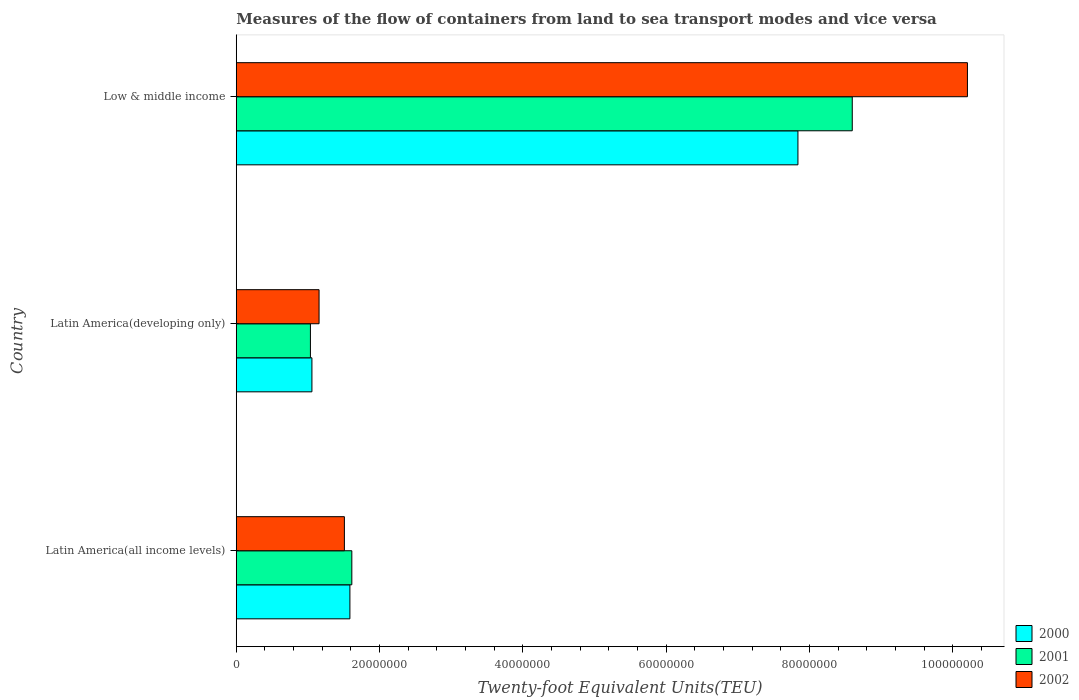How many different coloured bars are there?
Give a very brief answer. 3. How many groups of bars are there?
Offer a terse response. 3. Are the number of bars per tick equal to the number of legend labels?
Ensure brevity in your answer.  Yes. Are the number of bars on each tick of the Y-axis equal?
Make the answer very short. Yes. How many bars are there on the 2nd tick from the top?
Offer a terse response. 3. What is the label of the 2nd group of bars from the top?
Ensure brevity in your answer.  Latin America(developing only). In how many cases, is the number of bars for a given country not equal to the number of legend labels?
Keep it short and to the point. 0. What is the container port traffic in 2001 in Latin America(developing only)?
Offer a terse response. 1.04e+07. Across all countries, what is the maximum container port traffic in 2002?
Offer a terse response. 1.02e+08. Across all countries, what is the minimum container port traffic in 2001?
Offer a very short reply. 1.04e+07. In which country was the container port traffic in 2002 maximum?
Your answer should be compact. Low & middle income. In which country was the container port traffic in 2002 minimum?
Offer a terse response. Latin America(developing only). What is the total container port traffic in 2001 in the graph?
Provide a succinct answer. 1.12e+08. What is the difference between the container port traffic in 2002 in Latin America(all income levels) and that in Low & middle income?
Your response must be concise. -8.69e+07. What is the difference between the container port traffic in 2000 in Latin America(all income levels) and the container port traffic in 2002 in Low & middle income?
Ensure brevity in your answer.  -8.62e+07. What is the average container port traffic in 2000 per country?
Offer a terse response. 3.49e+07. What is the difference between the container port traffic in 2002 and container port traffic in 2000 in Latin America(all income levels)?
Ensure brevity in your answer.  -7.70e+05. In how many countries, is the container port traffic in 2001 greater than 64000000 TEU?
Your answer should be very brief. 1. What is the ratio of the container port traffic in 2002 in Latin America(developing only) to that in Low & middle income?
Offer a very short reply. 0.11. Is the container port traffic in 2002 in Latin America(all income levels) less than that in Latin America(developing only)?
Give a very brief answer. No. What is the difference between the highest and the second highest container port traffic in 2002?
Your response must be concise. 8.69e+07. What is the difference between the highest and the lowest container port traffic in 2002?
Provide a short and direct response. 9.05e+07. In how many countries, is the container port traffic in 2002 greater than the average container port traffic in 2002 taken over all countries?
Keep it short and to the point. 1. Is the sum of the container port traffic in 2002 in Latin America(developing only) and Low & middle income greater than the maximum container port traffic in 2001 across all countries?
Your answer should be very brief. Yes. What does the 2nd bar from the top in Latin America(developing only) represents?
Provide a short and direct response. 2001. What does the 3rd bar from the bottom in Latin America(developing only) represents?
Offer a very short reply. 2002. Is it the case that in every country, the sum of the container port traffic in 2001 and container port traffic in 2000 is greater than the container port traffic in 2002?
Your answer should be very brief. Yes. How many bars are there?
Your answer should be very brief. 9. What is the difference between two consecutive major ticks on the X-axis?
Give a very brief answer. 2.00e+07. Does the graph contain any zero values?
Ensure brevity in your answer.  No. Does the graph contain grids?
Ensure brevity in your answer.  No. Where does the legend appear in the graph?
Your answer should be very brief. Bottom right. How many legend labels are there?
Your answer should be very brief. 3. How are the legend labels stacked?
Give a very brief answer. Vertical. What is the title of the graph?
Provide a succinct answer. Measures of the flow of containers from land to sea transport modes and vice versa. Does "2009" appear as one of the legend labels in the graph?
Provide a succinct answer. No. What is the label or title of the X-axis?
Offer a terse response. Twenty-foot Equivalent Units(TEU). What is the label or title of the Y-axis?
Ensure brevity in your answer.  Country. What is the Twenty-foot Equivalent Units(TEU) of 2000 in Latin America(all income levels)?
Your response must be concise. 1.59e+07. What is the Twenty-foot Equivalent Units(TEU) of 2001 in Latin America(all income levels)?
Your response must be concise. 1.61e+07. What is the Twenty-foot Equivalent Units(TEU) in 2002 in Latin America(all income levels)?
Your answer should be very brief. 1.51e+07. What is the Twenty-foot Equivalent Units(TEU) in 2000 in Latin America(developing only)?
Your answer should be compact. 1.06e+07. What is the Twenty-foot Equivalent Units(TEU) in 2001 in Latin America(developing only)?
Your response must be concise. 1.04e+07. What is the Twenty-foot Equivalent Units(TEU) of 2002 in Latin America(developing only)?
Provide a short and direct response. 1.16e+07. What is the Twenty-foot Equivalent Units(TEU) in 2000 in Low & middle income?
Keep it short and to the point. 7.84e+07. What is the Twenty-foot Equivalent Units(TEU) in 2001 in Low & middle income?
Provide a short and direct response. 8.60e+07. What is the Twenty-foot Equivalent Units(TEU) of 2002 in Low & middle income?
Provide a succinct answer. 1.02e+08. Across all countries, what is the maximum Twenty-foot Equivalent Units(TEU) of 2000?
Offer a terse response. 7.84e+07. Across all countries, what is the maximum Twenty-foot Equivalent Units(TEU) in 2001?
Your answer should be very brief. 8.60e+07. Across all countries, what is the maximum Twenty-foot Equivalent Units(TEU) of 2002?
Ensure brevity in your answer.  1.02e+08. Across all countries, what is the minimum Twenty-foot Equivalent Units(TEU) in 2000?
Your response must be concise. 1.06e+07. Across all countries, what is the minimum Twenty-foot Equivalent Units(TEU) of 2001?
Your answer should be compact. 1.04e+07. Across all countries, what is the minimum Twenty-foot Equivalent Units(TEU) of 2002?
Make the answer very short. 1.16e+07. What is the total Twenty-foot Equivalent Units(TEU) of 2000 in the graph?
Provide a succinct answer. 1.05e+08. What is the total Twenty-foot Equivalent Units(TEU) in 2001 in the graph?
Make the answer very short. 1.12e+08. What is the total Twenty-foot Equivalent Units(TEU) in 2002 in the graph?
Give a very brief answer. 1.29e+08. What is the difference between the Twenty-foot Equivalent Units(TEU) of 2000 in Latin America(all income levels) and that in Latin America(developing only)?
Your answer should be very brief. 5.30e+06. What is the difference between the Twenty-foot Equivalent Units(TEU) in 2001 in Latin America(all income levels) and that in Latin America(developing only)?
Make the answer very short. 5.78e+06. What is the difference between the Twenty-foot Equivalent Units(TEU) of 2002 in Latin America(all income levels) and that in Latin America(developing only)?
Give a very brief answer. 3.53e+06. What is the difference between the Twenty-foot Equivalent Units(TEU) in 2000 in Latin America(all income levels) and that in Low & middle income?
Ensure brevity in your answer.  -6.25e+07. What is the difference between the Twenty-foot Equivalent Units(TEU) in 2001 in Latin America(all income levels) and that in Low & middle income?
Keep it short and to the point. -6.98e+07. What is the difference between the Twenty-foot Equivalent Units(TEU) of 2002 in Latin America(all income levels) and that in Low & middle income?
Ensure brevity in your answer.  -8.69e+07. What is the difference between the Twenty-foot Equivalent Units(TEU) of 2000 in Latin America(developing only) and that in Low & middle income?
Offer a very short reply. -6.78e+07. What is the difference between the Twenty-foot Equivalent Units(TEU) in 2001 in Latin America(developing only) and that in Low & middle income?
Your answer should be compact. -7.56e+07. What is the difference between the Twenty-foot Equivalent Units(TEU) in 2002 in Latin America(developing only) and that in Low & middle income?
Keep it short and to the point. -9.05e+07. What is the difference between the Twenty-foot Equivalent Units(TEU) of 2000 in Latin America(all income levels) and the Twenty-foot Equivalent Units(TEU) of 2001 in Latin America(developing only)?
Make the answer very short. 5.51e+06. What is the difference between the Twenty-foot Equivalent Units(TEU) of 2000 in Latin America(all income levels) and the Twenty-foot Equivalent Units(TEU) of 2002 in Latin America(developing only)?
Offer a very short reply. 4.30e+06. What is the difference between the Twenty-foot Equivalent Units(TEU) of 2001 in Latin America(all income levels) and the Twenty-foot Equivalent Units(TEU) of 2002 in Latin America(developing only)?
Offer a terse response. 4.57e+06. What is the difference between the Twenty-foot Equivalent Units(TEU) of 2000 in Latin America(all income levels) and the Twenty-foot Equivalent Units(TEU) of 2001 in Low & middle income?
Your answer should be very brief. -7.01e+07. What is the difference between the Twenty-foot Equivalent Units(TEU) of 2000 in Latin America(all income levels) and the Twenty-foot Equivalent Units(TEU) of 2002 in Low & middle income?
Make the answer very short. -8.62e+07. What is the difference between the Twenty-foot Equivalent Units(TEU) in 2001 in Latin America(all income levels) and the Twenty-foot Equivalent Units(TEU) in 2002 in Low & middle income?
Offer a very short reply. -8.59e+07. What is the difference between the Twenty-foot Equivalent Units(TEU) of 2000 in Latin America(developing only) and the Twenty-foot Equivalent Units(TEU) of 2001 in Low & middle income?
Make the answer very short. -7.54e+07. What is the difference between the Twenty-foot Equivalent Units(TEU) in 2000 in Latin America(developing only) and the Twenty-foot Equivalent Units(TEU) in 2002 in Low & middle income?
Ensure brevity in your answer.  -9.15e+07. What is the difference between the Twenty-foot Equivalent Units(TEU) in 2001 in Latin America(developing only) and the Twenty-foot Equivalent Units(TEU) in 2002 in Low & middle income?
Provide a short and direct response. -9.17e+07. What is the average Twenty-foot Equivalent Units(TEU) of 2000 per country?
Give a very brief answer. 3.49e+07. What is the average Twenty-foot Equivalent Units(TEU) of 2001 per country?
Give a very brief answer. 3.75e+07. What is the average Twenty-foot Equivalent Units(TEU) in 2002 per country?
Your answer should be very brief. 4.29e+07. What is the difference between the Twenty-foot Equivalent Units(TEU) in 2000 and Twenty-foot Equivalent Units(TEU) in 2001 in Latin America(all income levels)?
Offer a very short reply. -2.69e+05. What is the difference between the Twenty-foot Equivalent Units(TEU) in 2000 and Twenty-foot Equivalent Units(TEU) in 2002 in Latin America(all income levels)?
Offer a very short reply. 7.70e+05. What is the difference between the Twenty-foot Equivalent Units(TEU) in 2001 and Twenty-foot Equivalent Units(TEU) in 2002 in Latin America(all income levels)?
Your answer should be very brief. 1.04e+06. What is the difference between the Twenty-foot Equivalent Units(TEU) in 2000 and Twenty-foot Equivalent Units(TEU) in 2001 in Latin America(developing only)?
Offer a terse response. 2.09e+05. What is the difference between the Twenty-foot Equivalent Units(TEU) in 2000 and Twenty-foot Equivalent Units(TEU) in 2002 in Latin America(developing only)?
Your answer should be compact. -9.97e+05. What is the difference between the Twenty-foot Equivalent Units(TEU) of 2001 and Twenty-foot Equivalent Units(TEU) of 2002 in Latin America(developing only)?
Make the answer very short. -1.21e+06. What is the difference between the Twenty-foot Equivalent Units(TEU) of 2000 and Twenty-foot Equivalent Units(TEU) of 2001 in Low & middle income?
Ensure brevity in your answer.  -7.58e+06. What is the difference between the Twenty-foot Equivalent Units(TEU) in 2000 and Twenty-foot Equivalent Units(TEU) in 2002 in Low & middle income?
Keep it short and to the point. -2.37e+07. What is the difference between the Twenty-foot Equivalent Units(TEU) in 2001 and Twenty-foot Equivalent Units(TEU) in 2002 in Low & middle income?
Provide a succinct answer. -1.61e+07. What is the ratio of the Twenty-foot Equivalent Units(TEU) in 2000 in Latin America(all income levels) to that in Latin America(developing only)?
Provide a succinct answer. 1.5. What is the ratio of the Twenty-foot Equivalent Units(TEU) of 2001 in Latin America(all income levels) to that in Latin America(developing only)?
Your answer should be compact. 1.56. What is the ratio of the Twenty-foot Equivalent Units(TEU) of 2002 in Latin America(all income levels) to that in Latin America(developing only)?
Provide a short and direct response. 1.31. What is the ratio of the Twenty-foot Equivalent Units(TEU) of 2000 in Latin America(all income levels) to that in Low & middle income?
Your answer should be compact. 0.2. What is the ratio of the Twenty-foot Equivalent Units(TEU) of 2001 in Latin America(all income levels) to that in Low & middle income?
Offer a terse response. 0.19. What is the ratio of the Twenty-foot Equivalent Units(TEU) of 2002 in Latin America(all income levels) to that in Low & middle income?
Offer a very short reply. 0.15. What is the ratio of the Twenty-foot Equivalent Units(TEU) in 2000 in Latin America(developing only) to that in Low & middle income?
Keep it short and to the point. 0.13. What is the ratio of the Twenty-foot Equivalent Units(TEU) of 2001 in Latin America(developing only) to that in Low & middle income?
Offer a terse response. 0.12. What is the ratio of the Twenty-foot Equivalent Units(TEU) in 2002 in Latin America(developing only) to that in Low & middle income?
Offer a very short reply. 0.11. What is the difference between the highest and the second highest Twenty-foot Equivalent Units(TEU) in 2000?
Offer a terse response. 6.25e+07. What is the difference between the highest and the second highest Twenty-foot Equivalent Units(TEU) in 2001?
Offer a very short reply. 6.98e+07. What is the difference between the highest and the second highest Twenty-foot Equivalent Units(TEU) in 2002?
Make the answer very short. 8.69e+07. What is the difference between the highest and the lowest Twenty-foot Equivalent Units(TEU) of 2000?
Your answer should be very brief. 6.78e+07. What is the difference between the highest and the lowest Twenty-foot Equivalent Units(TEU) of 2001?
Offer a very short reply. 7.56e+07. What is the difference between the highest and the lowest Twenty-foot Equivalent Units(TEU) of 2002?
Offer a very short reply. 9.05e+07. 